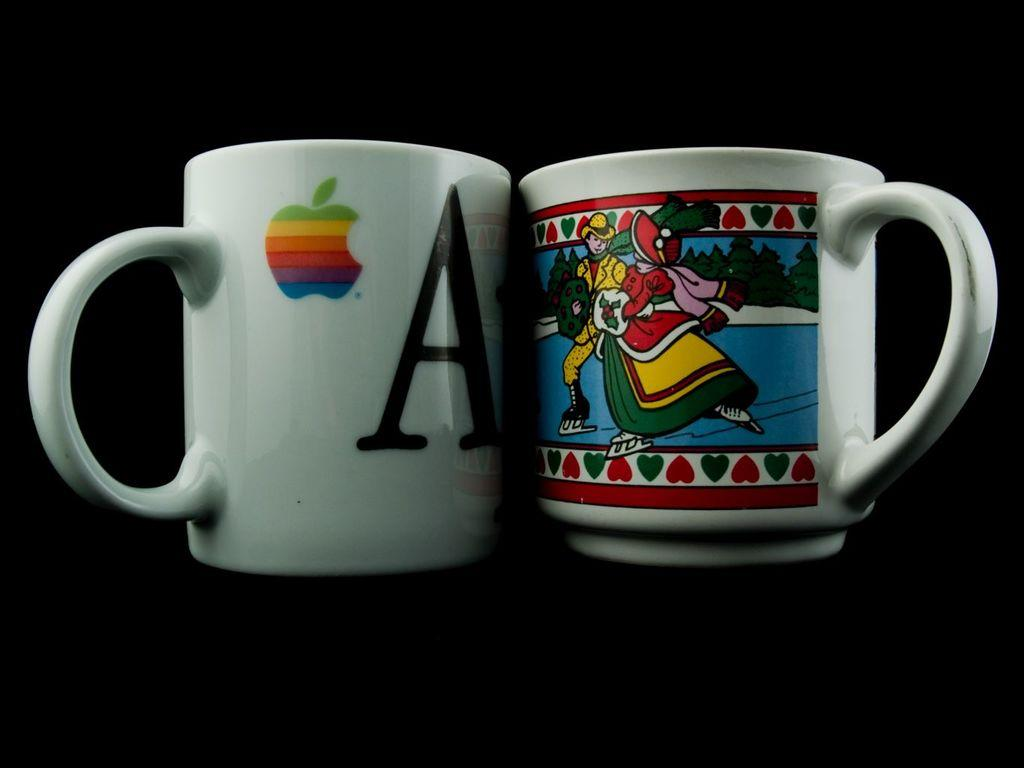<image>
Relay a brief, clear account of the picture shown. Two coffee mugs, one of which has a large letter "A" on it. 